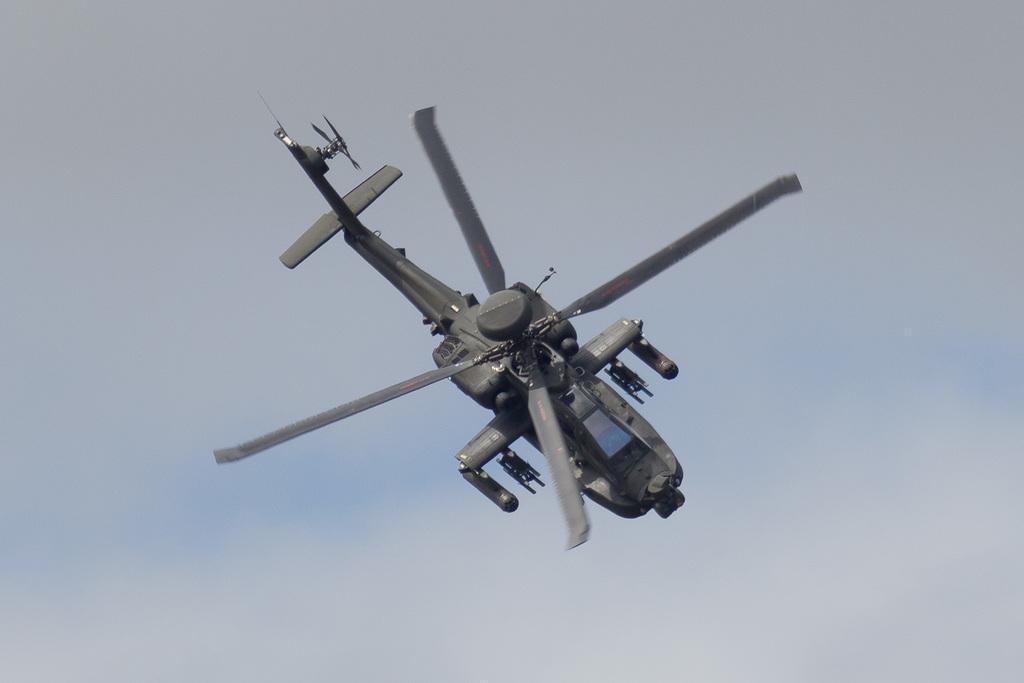In one or two sentences, can you explain what this image depicts? In the center of the image we can see a helicopter flying in the sky. 